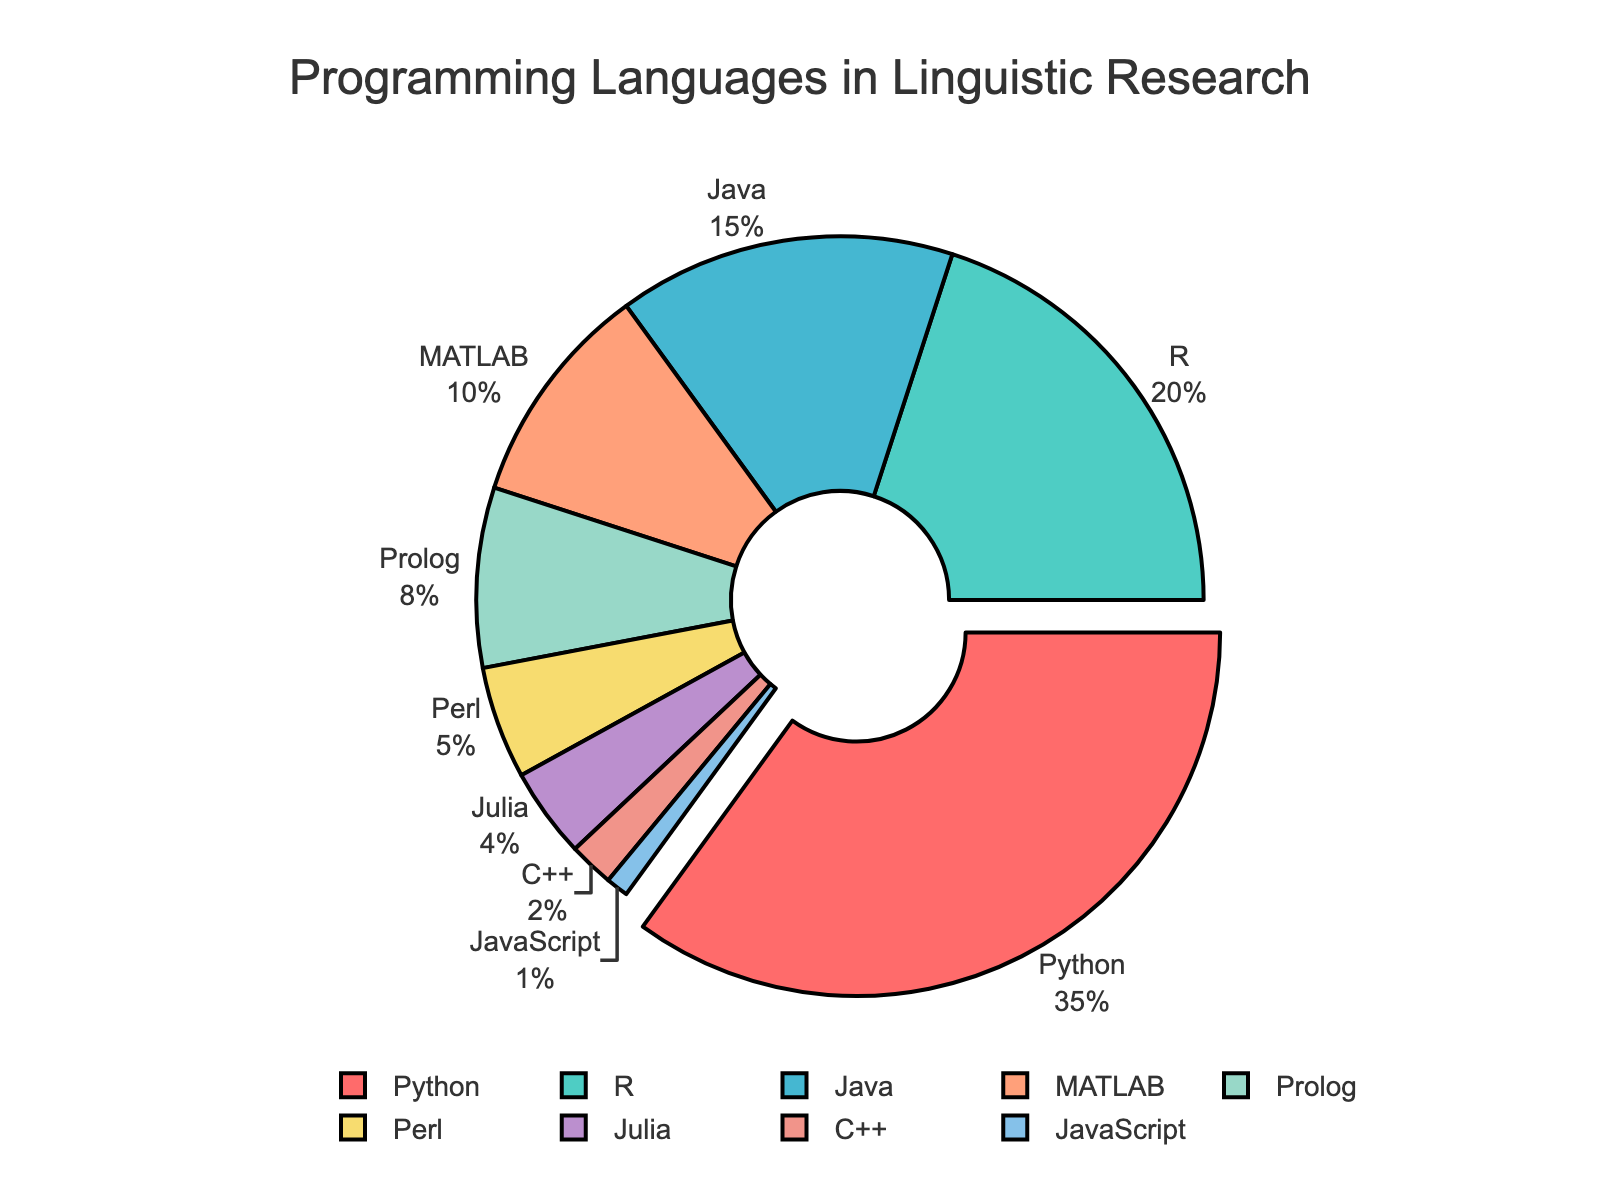Which programming language is used the most in linguistic research? Looking at the pie chart, it shows that Python occupies the largest segment. The slice representing Python is also pulled out from the pie, indicating it has the highest proportion.
Answer: Python Which two programming languages together account for more than half of the linguistic research usage? To find this, we sum the percentages of the top two languages. Python has 35%, and R has 20%. Adding these together, 35% + 20% = 55%. Since 55% is more than half, Python and R together account for more than half.
Answer: Python and R What proportion of research uses MATLAB compared to Julia? MATLAB has a segment showing 10%, and Julia has a segment showing 4%. To find the proportion of MATLAB to Julia, we divide MATLAB's percentage by Julia's percentage: 10% / 4% = 2.5.
Answer: 2.5 By how much does the usage of Java exceed that of C++? Java's usage is 15%, and C++'s usage is 2%. To find the difference, we subtract C++'s percentage from Java's percentage: 15% - 2% = 13%.
Answer: 13% Which programming language is least utilized in linguistic research? The pie chart shows that JavaScript has the smallest segment, indicating it has the lowest percentage usage.
Answer: JavaScript What percentage of programming languages collectively accounts for less than 10% usage each? Identifying each language with less than 10%: Prolog (8%), Perl (5%), Julia (4%), C++ (2%), JavaScript (1%). Summing these percentages: 8% + 5% + 4% + 2% + 1% = 20%.
Answer: 20% Which segment next to Python is the first language not in the top three most-used languages? The top three languages are Python (35%), R (20%), and Java (15%). The next segment is for MATLAB at 10%. The first language not in the top three next to Python in the chart is MATLAB.
Answer: MATLAB Would removing R and Prolog together result in a combined usage less than that of Python alone? R has 20% and Prolog has 8%, so together they make 20% + 8% = 28%. Python alone already has 35%. Thus, removing R and Prolog would result in a combined usage of 28%, which is less than Python alone.
Answer: Yes 